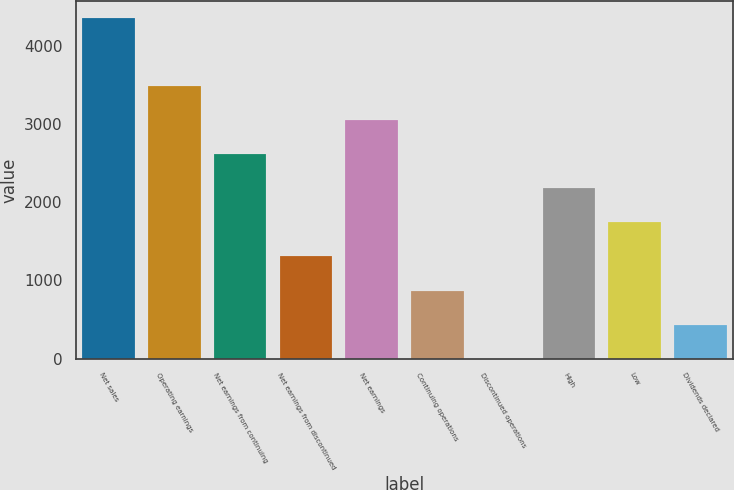<chart> <loc_0><loc_0><loc_500><loc_500><bar_chart><fcel>Net sales<fcel>Operating earnings<fcel>Net earnings from continuing<fcel>Net earnings from discontinued<fcel>Net earnings<fcel>Continuing operations<fcel>Discontinued operations<fcel>High<fcel>Low<fcel>Dividends declared<nl><fcel>4355<fcel>3483.99<fcel>2613.01<fcel>1306.54<fcel>3048.5<fcel>871.05<fcel>0.07<fcel>2177.52<fcel>1742.03<fcel>435.56<nl></chart> 